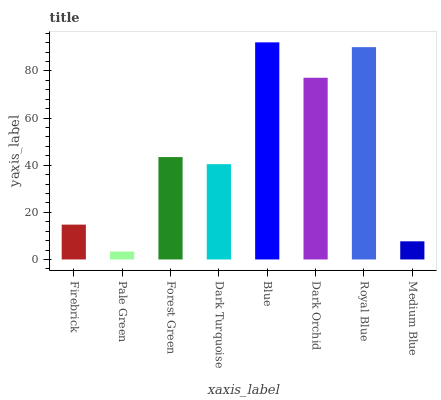Is Pale Green the minimum?
Answer yes or no. Yes. Is Blue the maximum?
Answer yes or no. Yes. Is Forest Green the minimum?
Answer yes or no. No. Is Forest Green the maximum?
Answer yes or no. No. Is Forest Green greater than Pale Green?
Answer yes or no. Yes. Is Pale Green less than Forest Green?
Answer yes or no. Yes. Is Pale Green greater than Forest Green?
Answer yes or no. No. Is Forest Green less than Pale Green?
Answer yes or no. No. Is Forest Green the high median?
Answer yes or no. Yes. Is Dark Turquoise the low median?
Answer yes or no. Yes. Is Pale Green the high median?
Answer yes or no. No. Is Dark Orchid the low median?
Answer yes or no. No. 